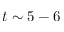Convert formula to latex. <formula><loc_0><loc_0><loc_500><loc_500>t \sim 5 - 6</formula> 